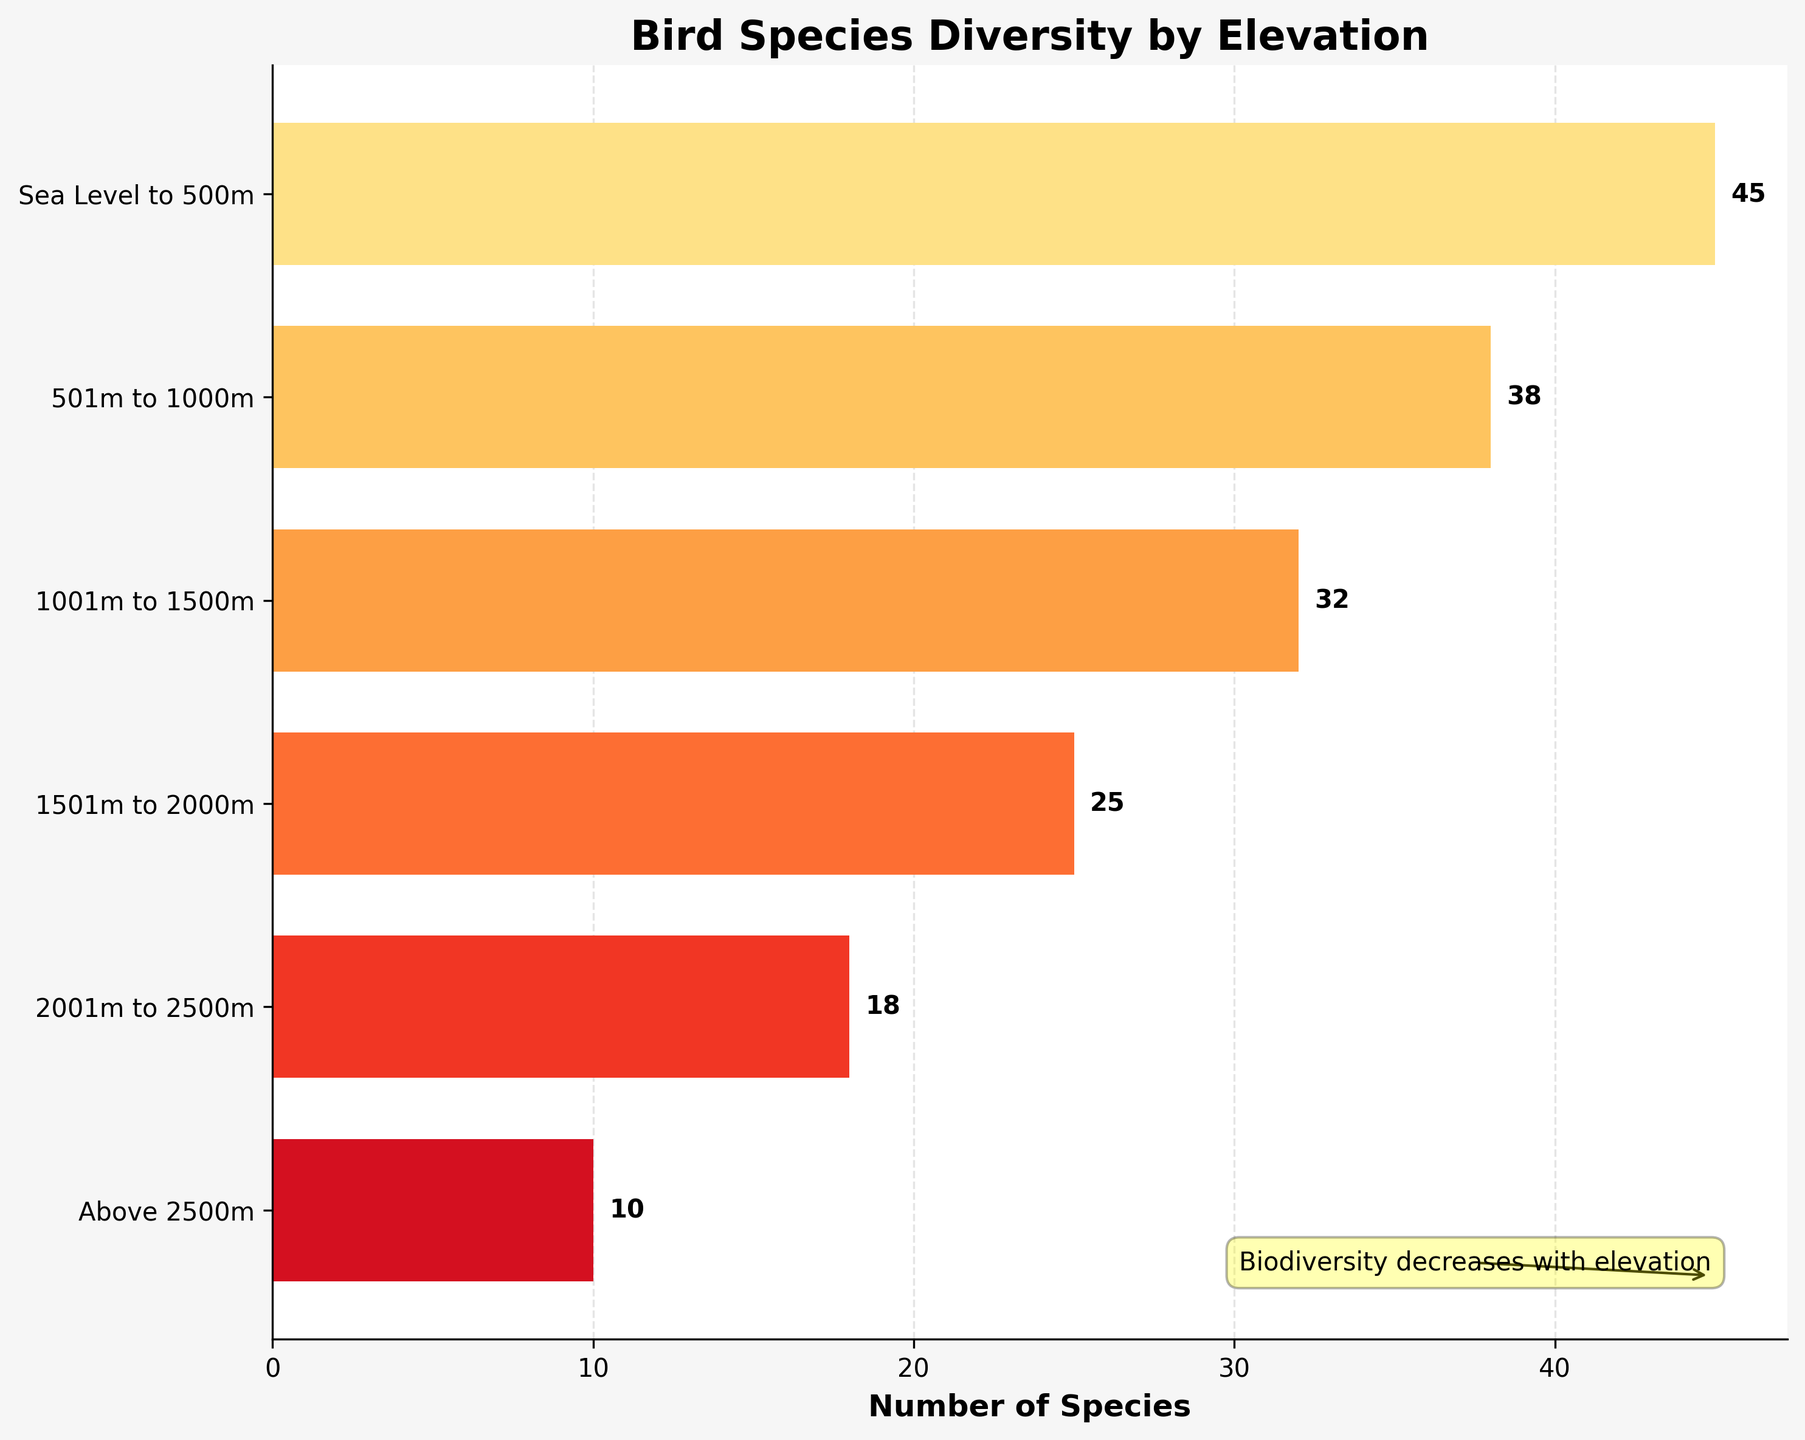What is the title of the chart? The title is located at the top of the chart and is usually in bold text.
Answer: Bird Species Diversity by Elevation How many sections are shown in the chart? The chart segments correspond to different elevation levels. By counting the segments from bottom to top, we identify the number of elevation ranges.
Answer: 6 Which elevation range has the highest number of bird species? Look for the longest bar on the chart, which indicates the highest number of species.
Answer: Sea Level to 500m How does species diversity change as elevation increases? Observe the trend in the lengths of the bars from bottom to top, noticing if they increase or decrease. The bars generally shorten as you go up the elevation scale.
Answer: It decreases What is the combined number of bird species observed from sea level to 1000m? Sum the number of species for the first two elevation ranges: 45 (Sea Level to 500m) + 38 (501m to 1000m).
Answer: 83 How many more species are there at the mid-montane level compared to the alpine level? Subtract the number of species at the alpine level from the mid-montane level: 32 (mid-montane) - 10 (alpine).
Answer: 22 Which elevation range shows the least number of bird species? Identify the shortest bar on the chart, which corresponds to the elevation with the fewest species.
Answer: Above 2500m What is the average number of species observed per elevation level? Calculate the average by summing the number of species across all elevation ranges and then dividing by the number of elevation ranges. (45 + 38 + 32 + 25 + 18 + 10) / 6.
Answer: 28 Between which neighboring elevation levels is the greatest drop in bird species observed? Examine the differences in species counts between each pair of neighboring elevation levels and identify the pair with the largest difference. The difference from 'Sea Level to 500m' to '501m to 1000m' is 7, from '501m to 1000m' to '1001m to 1500m' is 6, from '1001m to 1500m' to '1501m to 2000m' is 7, from '1501m to 2000m' to '2001m to 2500m' is 7, and from '2001m to 2500m' to 'Above 2500m' is 8. Hence, the largest drop is between '2001m to 2500m' and 'Above 2500m'
Answer: Between 2001m to 2500m and Above 2500m 